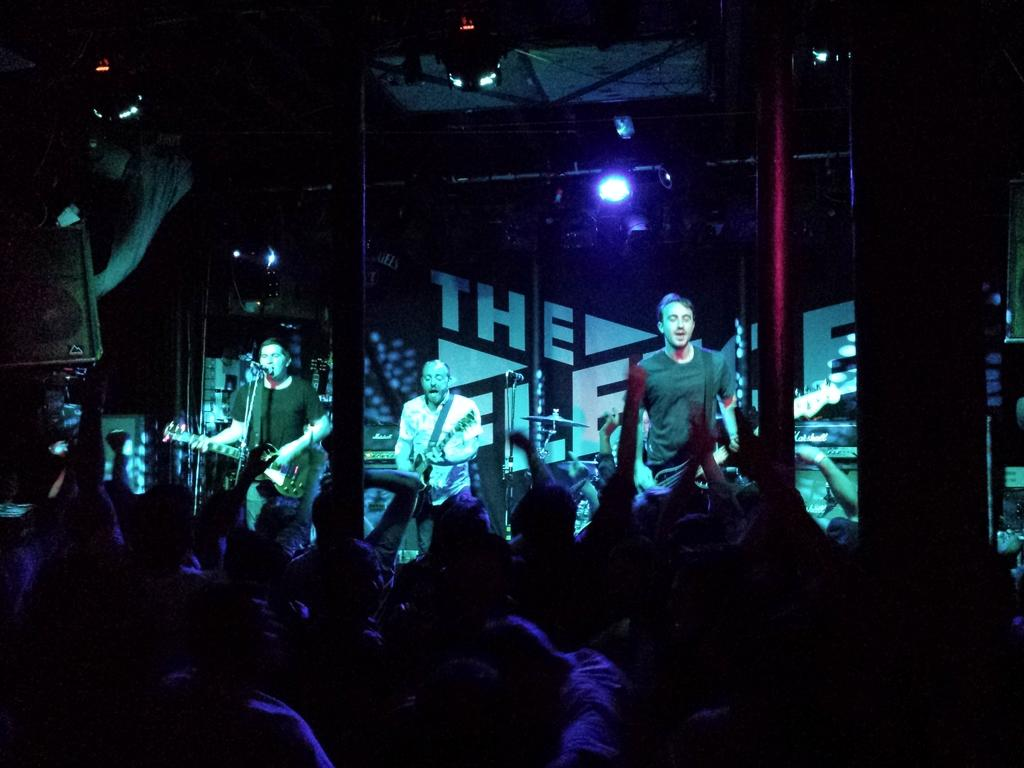How many men are in the image? There are three men in the image. What are the men doing in the image? The men are standing in front of microphones and playing guitars. Are there any other people visible in the image? Yes, there are people visible at the bottom of the image. What can be seen in the image that provides lighting? There are lights in the image. What objects are present in the image that might be used for support or structure? There are poles in the image. Where is the scarecrow located in the image? There is no scarecrow present in the image. What type of boat can be seen in the image? There is no boat present in the image. 